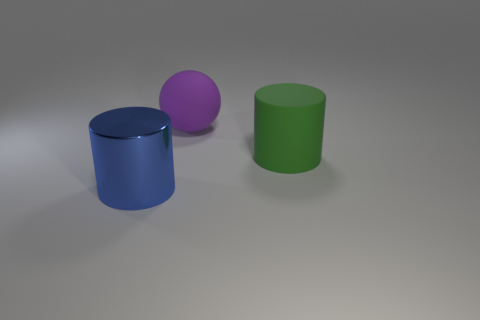Add 1 big purple spheres. How many objects exist? 4 Subtract all spheres. How many objects are left? 2 Add 2 small blue metal things. How many small blue metal things exist? 2 Subtract 0 cyan cylinders. How many objects are left? 3 Subtract all big purple metallic things. Subtract all large purple spheres. How many objects are left? 2 Add 1 blue cylinders. How many blue cylinders are left? 2 